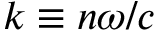<formula> <loc_0><loc_0><loc_500><loc_500>k \equiv n \omega / c</formula> 